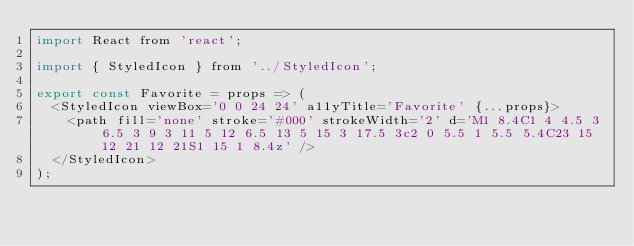<code> <loc_0><loc_0><loc_500><loc_500><_JavaScript_>import React from 'react';

import { StyledIcon } from '../StyledIcon';

export const Favorite = props => (
  <StyledIcon viewBox='0 0 24 24' a11yTitle='Favorite' {...props}>
    <path fill='none' stroke='#000' strokeWidth='2' d='M1 8.4C1 4 4.5 3 6.5 3 9 3 11 5 12 6.5 13 5 15 3 17.5 3c2 0 5.5 1 5.5 5.4C23 15 12 21 12 21S1 15 1 8.4z' />
  </StyledIcon>
);
</code> 